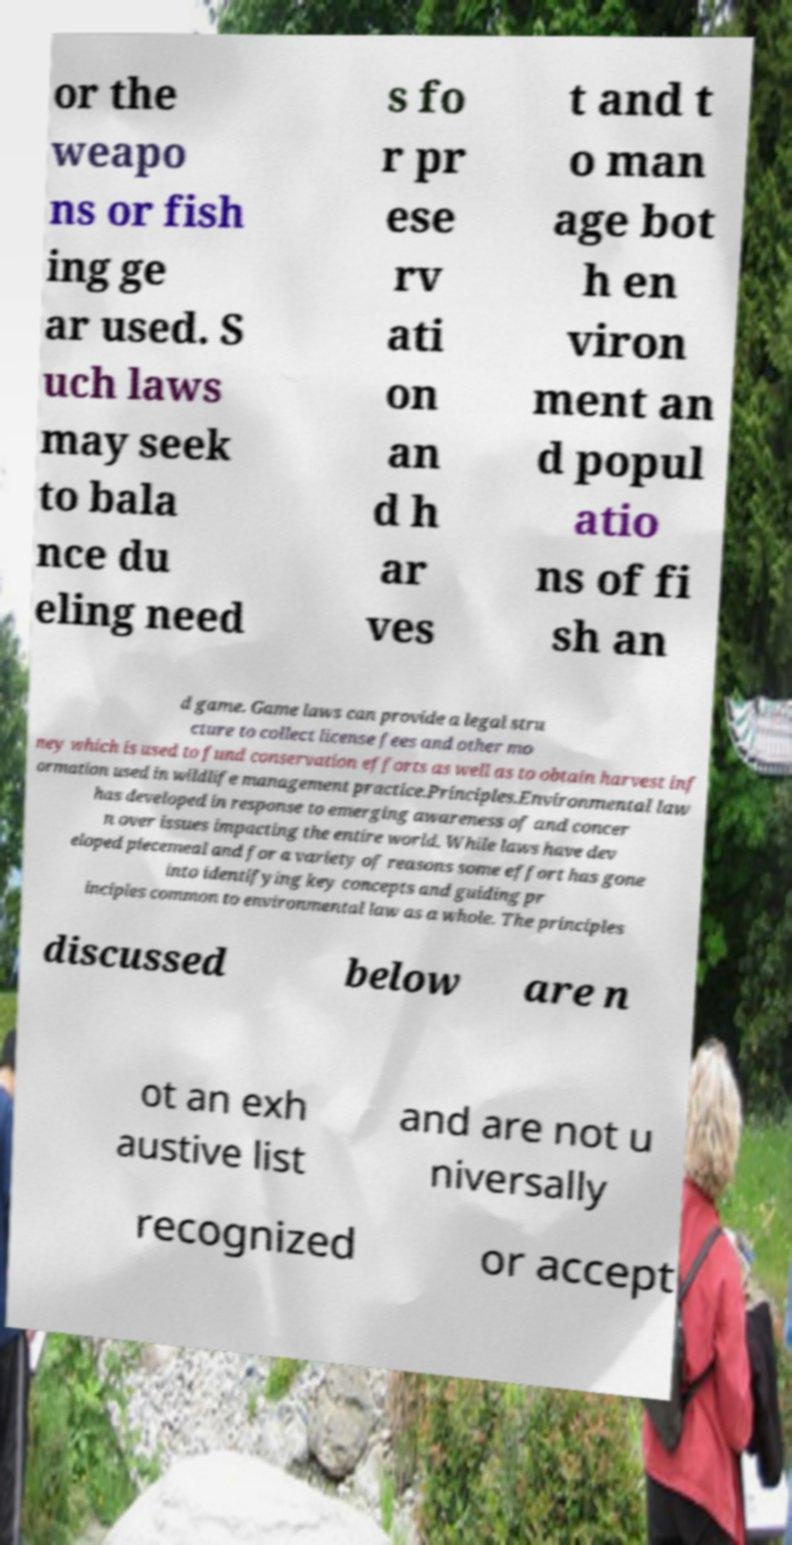Please read and relay the text visible in this image. What does it say? or the weapo ns or fish ing ge ar used. S uch laws may seek to bala nce du eling need s fo r pr ese rv ati on an d h ar ves t and t o man age bot h en viron ment an d popul atio ns of fi sh an d game. Game laws can provide a legal stru cture to collect license fees and other mo ney which is used to fund conservation efforts as well as to obtain harvest inf ormation used in wildlife management practice.Principles.Environmental law has developed in response to emerging awareness of and concer n over issues impacting the entire world. While laws have dev eloped piecemeal and for a variety of reasons some effort has gone into identifying key concepts and guiding pr inciples common to environmental law as a whole. The principles discussed below are n ot an exh austive list and are not u niversally recognized or accept 